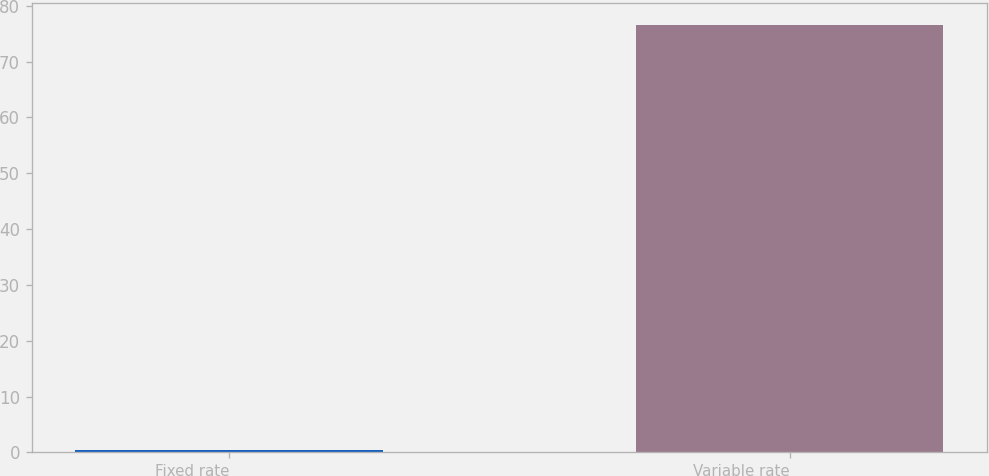Convert chart to OTSL. <chart><loc_0><loc_0><loc_500><loc_500><bar_chart><fcel>Fixed rate<fcel>Variable rate<nl><fcel>0.5<fcel>76.6<nl></chart> 